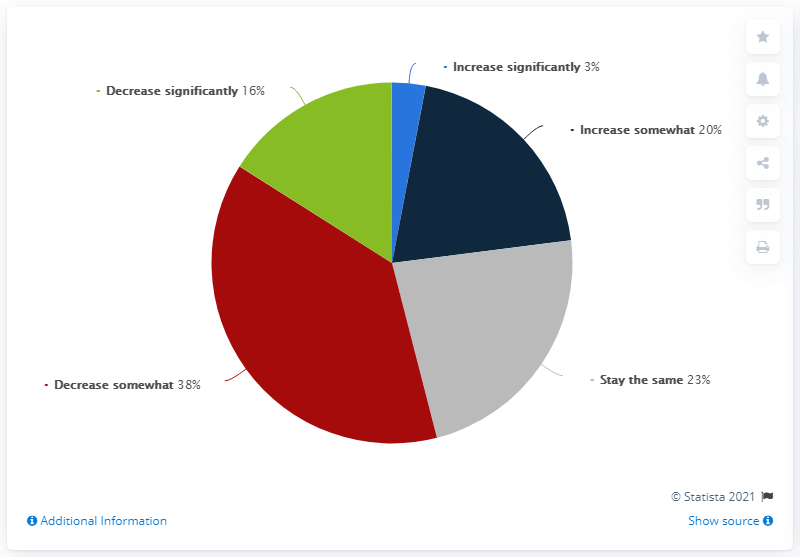Indicate a few pertinent items in this graphic. The most popular trend in the pie chart is a decrease, although it is not as significant as in previous years. The total share of increasing debts is 23 percent. 